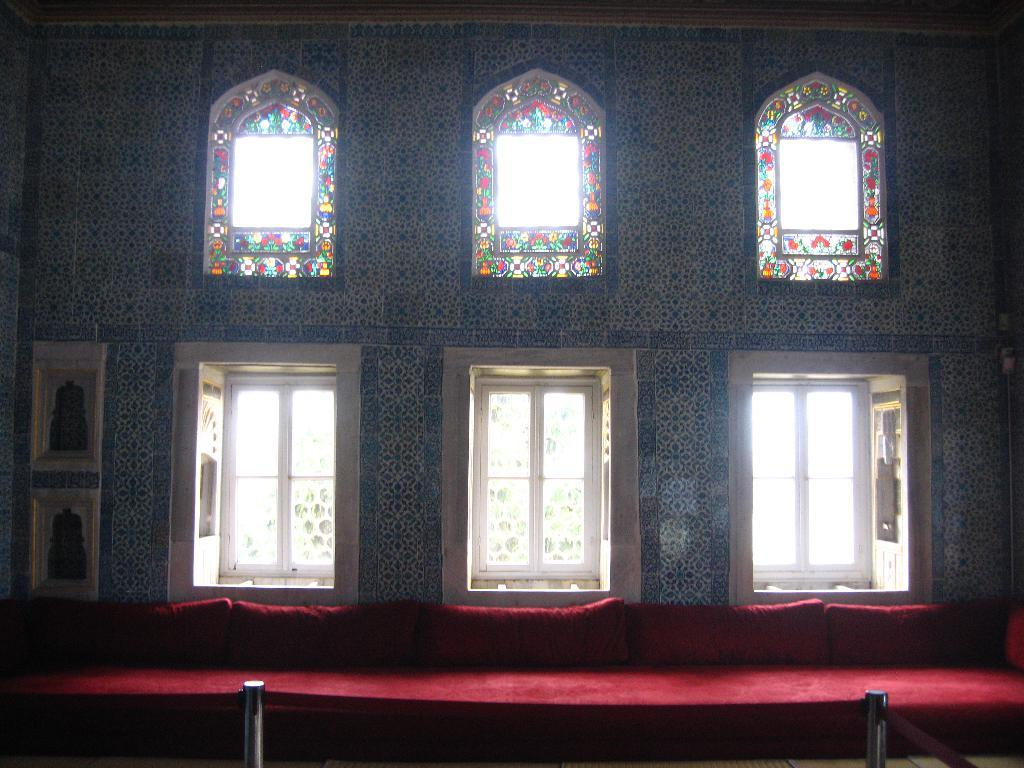What is on the stage in the image? There is a carpet on the stage in the image. What can be seen in the background of the image? There are windows visible in the background of the image. What is behind the windows in the image? There is a wall behind the windows in the image. What type of drain is visible on the carpet in the image? There is no drain present on the carpet in the image. 